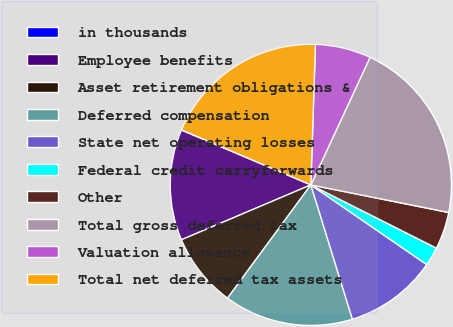Convert chart. <chart><loc_0><loc_0><loc_500><loc_500><pie_chart><fcel>in thousands<fcel>Employee benefits<fcel>Asset retirement obligations &<fcel>Deferred compensation<fcel>State net operating losses<fcel>Federal credit carryforwards<fcel>Other<fcel>Total gross deferred tax<fcel>Valuation allowance<fcel>Total net deferred tax assets<nl><fcel>0.04%<fcel>12.75%<fcel>8.52%<fcel>14.87%<fcel>10.64%<fcel>2.16%<fcel>4.28%<fcel>21.23%<fcel>6.4%<fcel>19.11%<nl></chart> 